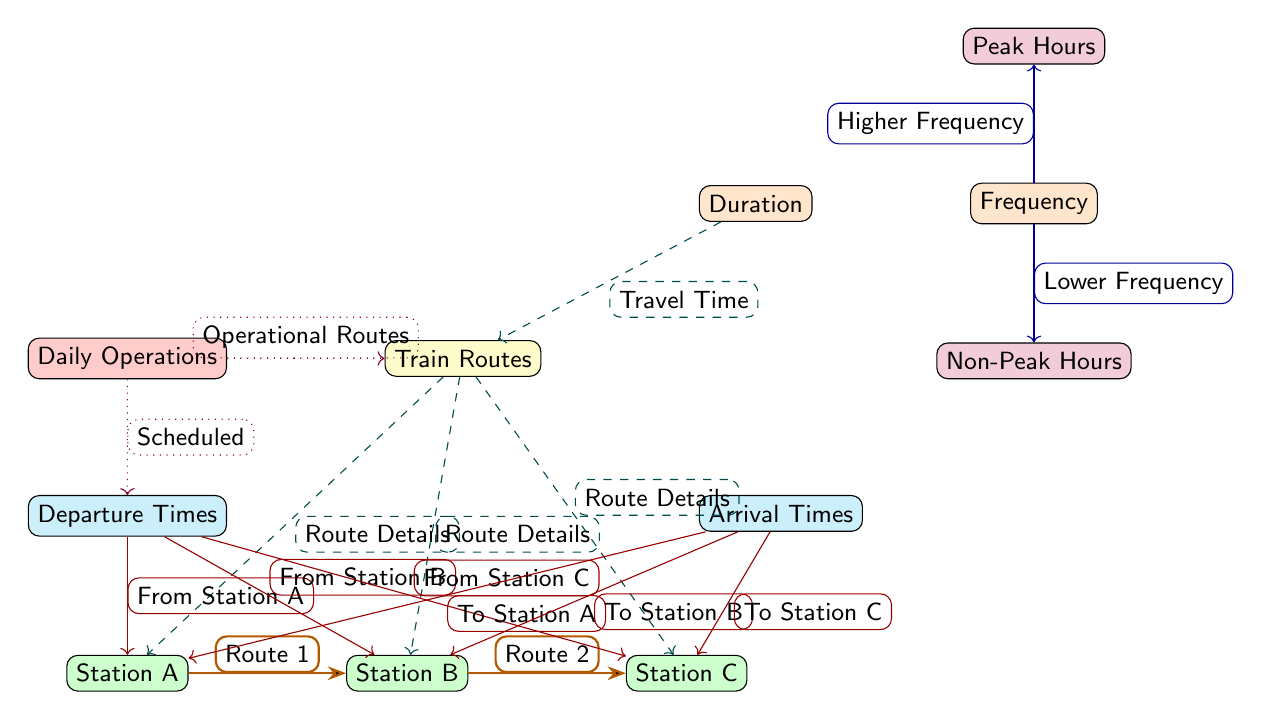What are the three train routes depicted in the diagram? The diagram shows two connections: Route 1 from Station A to Station B and Route 2 from Station B to Station C. Since no additional routes are mentioned, the answer is limited to these two routes.
Answer: Route 1, Route 2 What is the travel time associated with the routes? The diagram contains a connection labeled "Travel Time" that links the duration node to the routes node. However, it does not specify a numerical time; thus, it is not possible to provide a specific travel time from the diagram.
Answer: Not specified Which node represents the non-peak hours? In the diagram, the non-peak hours are represented by the node labeled "Non-Peak Hours," which is located below the frequency node.
Answer: Non-Peak Hours How many total stations are depicted in the diagram? The diagram has three stations: Station A, Station B, and Station C. By counting these nodes, we find a total of three stations.
Answer: 3 Which two factors are linked to frequency in the diagram? The diagram illustrates two arrows emanating from the frequency node: one leads to "Higher Frequency," and the other to "Lower Frequency." Both terms indicate how frequency can vary.
Answer: Higher Frequency, Lower Frequency What type of operations is indicated as daily in the diagram? The node labeled "Daily Operations" is connected by a dotted arrow to the routes node, meaning all operational routes are conducted daily.
Answer: Operational Routes What does the dashed line from 'Routes' to 'Departure Times' signify? This dashed line denotes a relationship that indicates that the departure times are tied to route details, meaning that specific departures align with specific routes.
Answer: Route Details What is the purpose of the orange node labeled 'Duration'? The orange node labeled 'Duration' serves to represent the travel time information associated with the various routes in the diagram.
Answer: Travel Time How do peak hours relate to frequency in the diagram? The diagram connects the frequency node to the peak hours node with an arrow labeled “Higher Frequency,” indicating that frequency is typically higher during peak hours.
Answer: Higher Frequency 